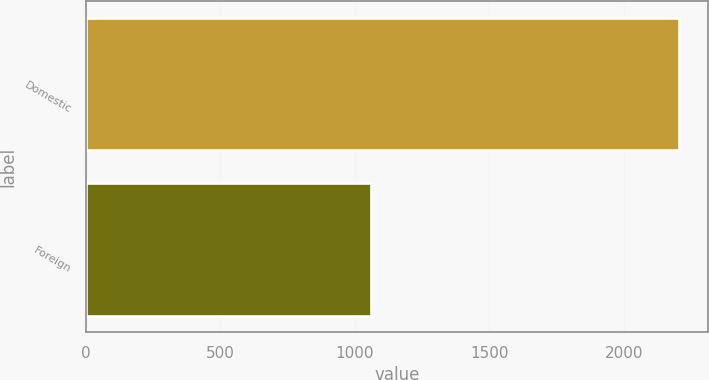Convert chart. <chart><loc_0><loc_0><loc_500><loc_500><bar_chart><fcel>Domestic<fcel>Foreign<nl><fcel>2204<fcel>1061<nl></chart> 